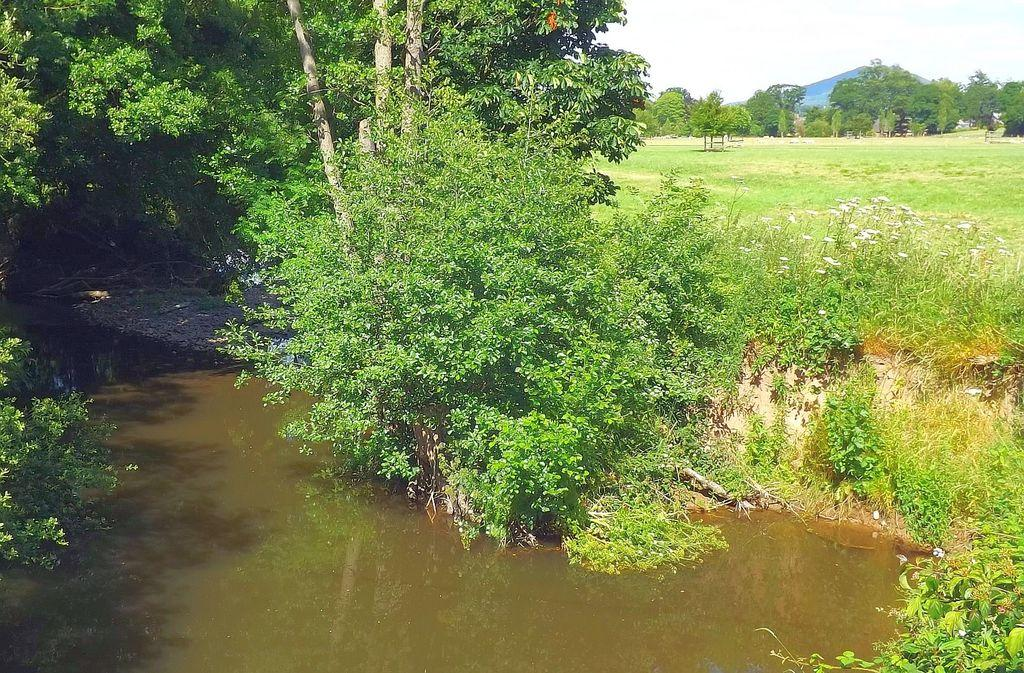What is located in the foreground of the image? There is a river in the foreground of the image. What type of vegetation is present near the river? Trees are present beside the river. What can be seen in the background of the image? There is grass, flowers, trees, and a mountain in the background. What is visible in the sky in the image? The sky is visible in the image. What type of cracker is being used to build a coil around the pigs in the image? There are no crackers, pigs, or coils present in the image. 